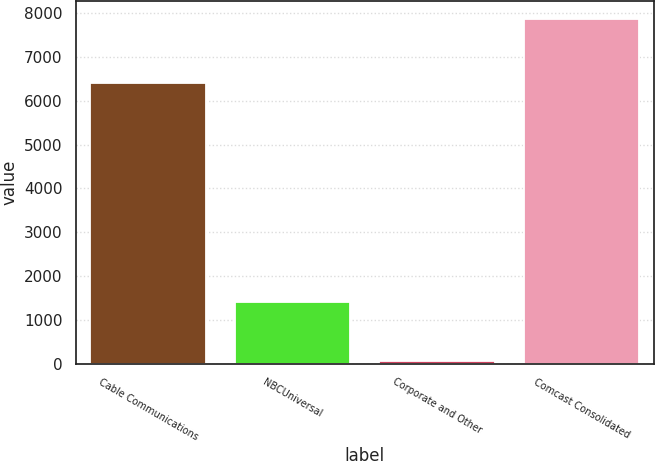Convert chart. <chart><loc_0><loc_0><loc_500><loc_500><bar_chart><fcel>Cable Communications<fcel>NBCUniversal<fcel>Corporate and Other<fcel>Comcast Consolidated<nl><fcel>6394<fcel>1411<fcel>66<fcel>7871<nl></chart> 